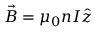<formula> <loc_0><loc_0><loc_500><loc_500>\vec { B } = \mu _ { 0 } n I \hat { z }</formula> 